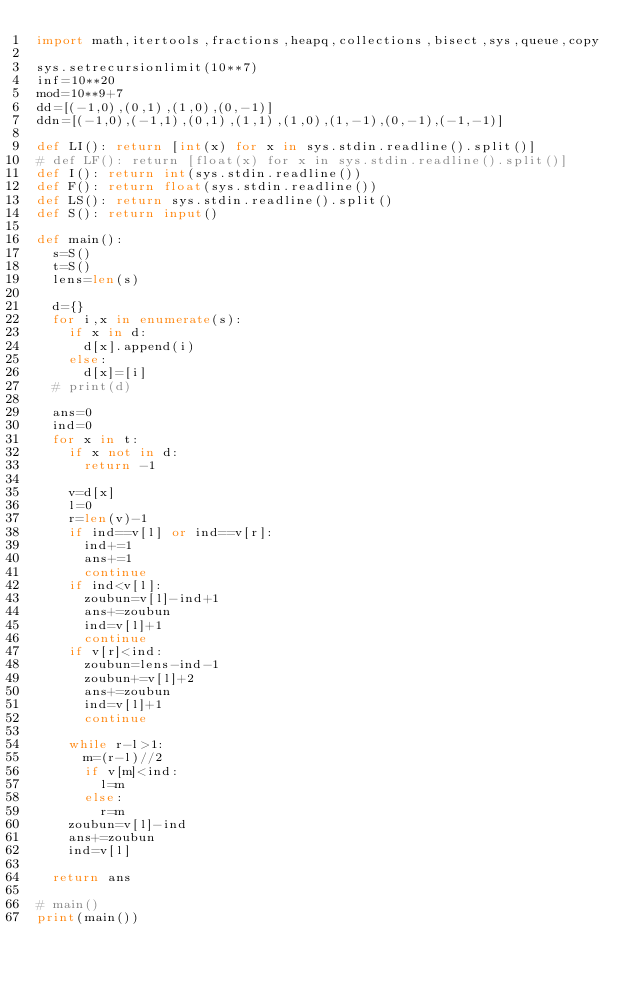<code> <loc_0><loc_0><loc_500><loc_500><_Python_>import math,itertools,fractions,heapq,collections,bisect,sys,queue,copy

sys.setrecursionlimit(10**7)
inf=10**20
mod=10**9+7
dd=[(-1,0),(0,1),(1,0),(0,-1)]
ddn=[(-1,0),(-1,1),(0,1),(1,1),(1,0),(1,-1),(0,-1),(-1,-1)]

def LI(): return [int(x) for x in sys.stdin.readline().split()]
# def LF(): return [float(x) for x in sys.stdin.readline().split()]
def I(): return int(sys.stdin.readline())
def F(): return float(sys.stdin.readline())
def LS(): return sys.stdin.readline().split()
def S(): return input()

def main():
  s=S()
  t=S()
  lens=len(s)

  d={}
  for i,x in enumerate(s):
    if x in d:
      d[x].append(i)
    else:
      d[x]=[i]
  # print(d)

  ans=0
  ind=0
  for x in t:
    if x not in d:
      return -1

    v=d[x]
    l=0
    r=len(v)-1
    if ind==v[l] or ind==v[r]:
      ind+=1
      ans+=1
      continue
    if ind<v[l]:
      zoubun=v[l]-ind+1
      ans+=zoubun
      ind=v[l]+1
      continue
    if v[r]<ind:
      zoubun=lens-ind-1
      zoubun+=v[l]+2
      ans+=zoubun
      ind=v[l]+1
      continue

    while r-l>1:
      m=(r-l)//2
      if v[m]<ind:
        l=m
      else:
        r=m
    zoubun=v[l]-ind
    ans+=zoubun
    ind=v[l]

  return ans

# main()
print(main())
</code> 